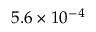Convert formula to latex. <formula><loc_0><loc_0><loc_500><loc_500>5 . 6 \times 1 0 ^ { - 4 }</formula> 